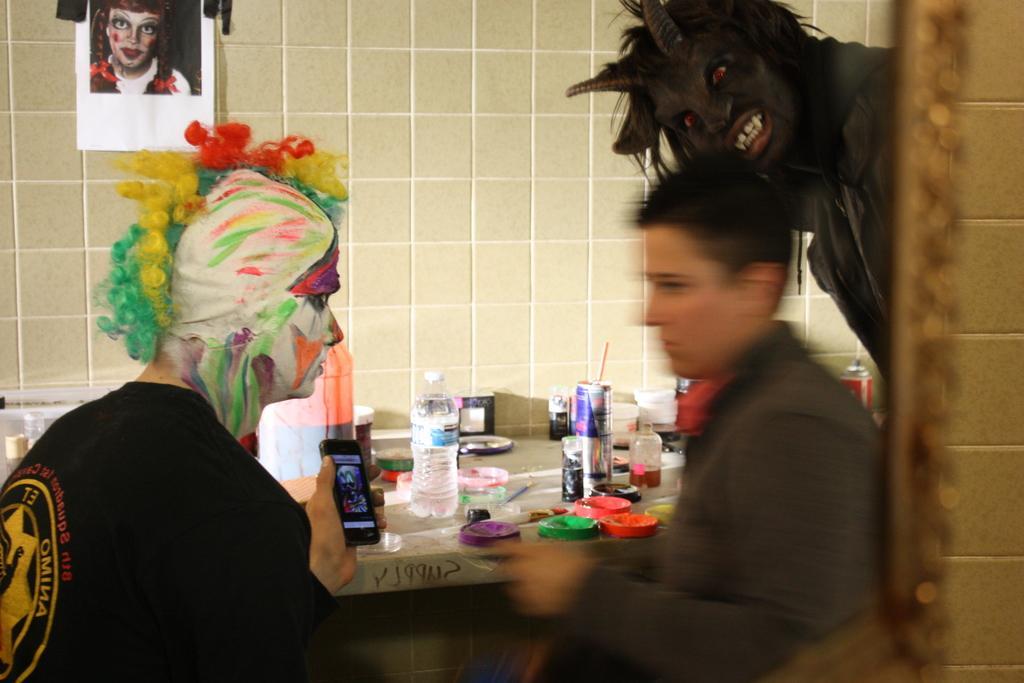Could you give a brief overview of what you see in this image? In the foreground of this image, there is a man on the right and a man on the left who is having paintings on his face and a wig on his head. Behind them, there is a man on the right with devil make up. In the background, there are bottles, bowl, cups, tins and few more objects and a poster on the wall. 